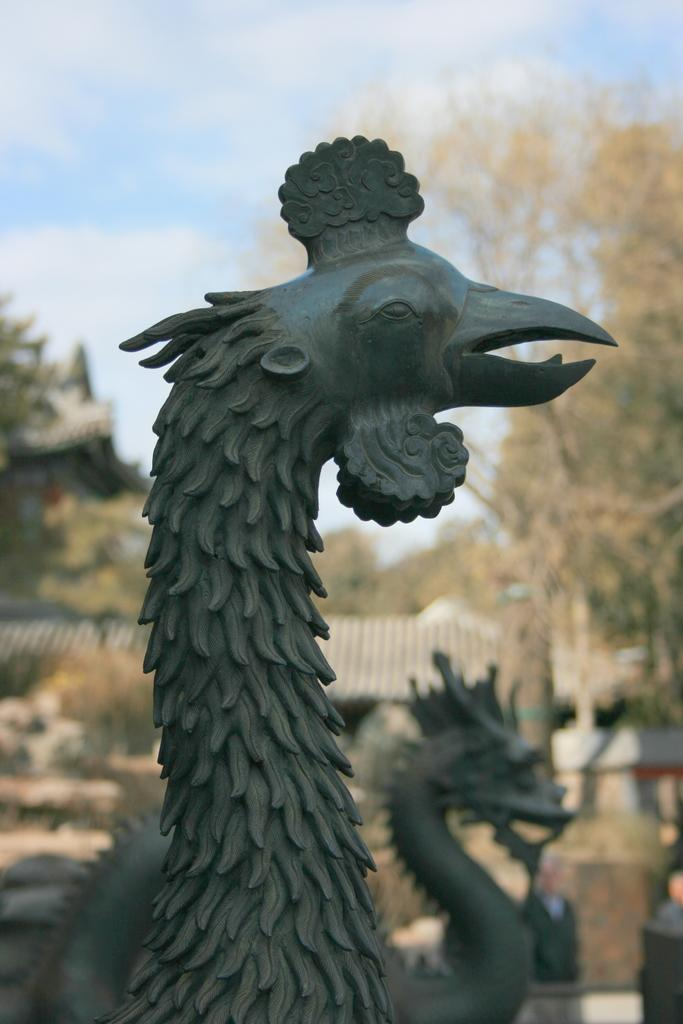What is located in the middle of the image? There are statues in the middle of the image. What can be seen behind the statues? There are trees and buildings behind the statues. What is visible at the top of the image? Clouds and the sky are visible at the top of the image. What type of government is depicted in the image? There is no depiction of a government in the image; it features statues, trees, buildings, clouds, and the sky. Can you tell me how many times the statues have been burned in the image? There is no indication of any burning or damage to the statues in the image. 